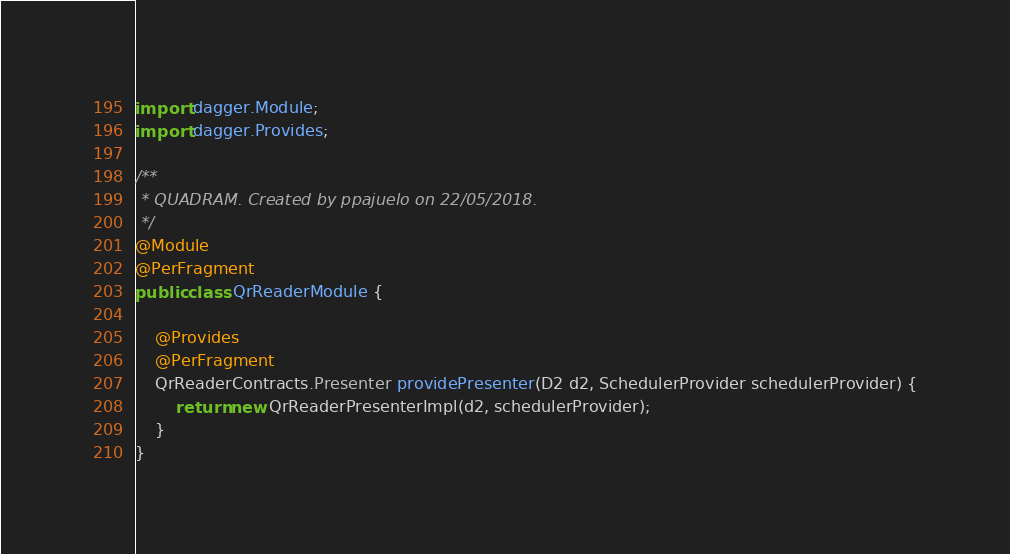<code> <loc_0><loc_0><loc_500><loc_500><_Java_>
import dagger.Module;
import dagger.Provides;

/**
 * QUADRAM. Created by ppajuelo on 22/05/2018.
 */
@Module
@PerFragment
public class QrReaderModule {

    @Provides
    @PerFragment
    QrReaderContracts.Presenter providePresenter(D2 d2, SchedulerProvider schedulerProvider) {
        return new QrReaderPresenterImpl(d2, schedulerProvider);
    }
}
</code> 